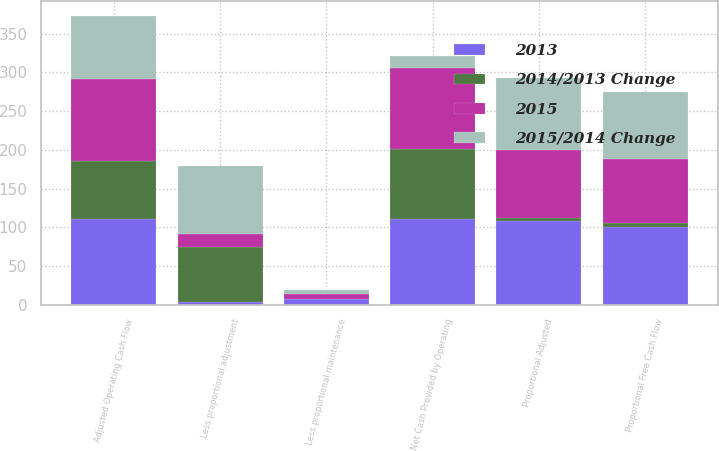<chart> <loc_0><loc_0><loc_500><loc_500><stacked_bar_chart><ecel><fcel>Net Cash Provided by Operating<fcel>Adjusted Operating Cash Flow<fcel>Less proportional adjustment<fcel>Proportional Adjusted<fcel>Less proportional maintenance<fcel>Proportional Free Cash Flow<nl><fcel>2015/2014 Change<fcel>15<fcel>82<fcel>88<fcel>92<fcel>5<fcel>87<nl><fcel>2015<fcel>105<fcel>105<fcel>17<fcel>88<fcel>6<fcel>82<nl><fcel>2013<fcel>111<fcel>111<fcel>3<fcel>108<fcel>7<fcel>101<nl><fcel>2014/2013 Change<fcel>90<fcel>75<fcel>71<fcel>4<fcel>1<fcel>5<nl></chart> 